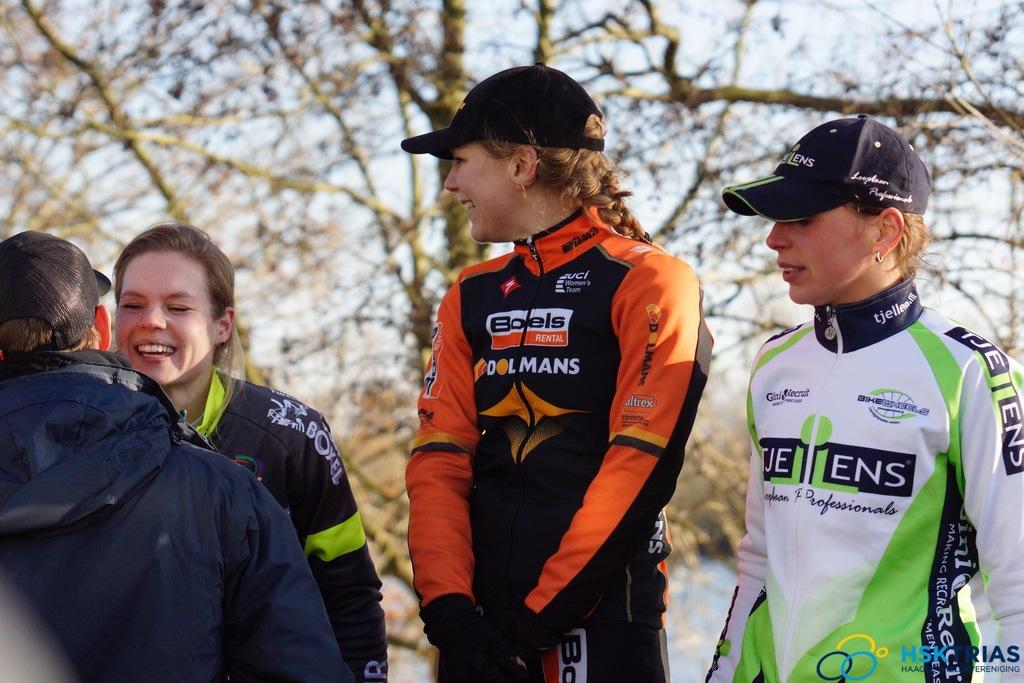Who sponsors the lady in orange?
Your answer should be very brief. Boels. What word is in cursive font on the white jacket?
Ensure brevity in your answer.  Professionals. 